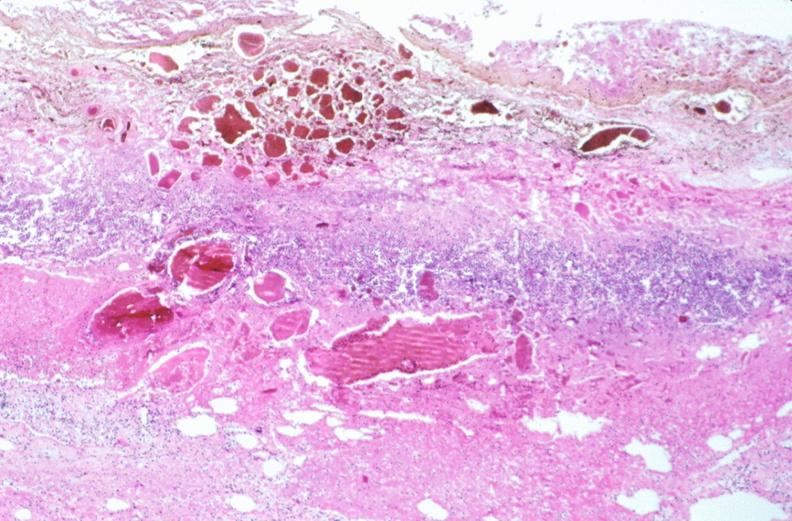what is present?
Answer the question using a single word or phrase. Gastrointestinal 